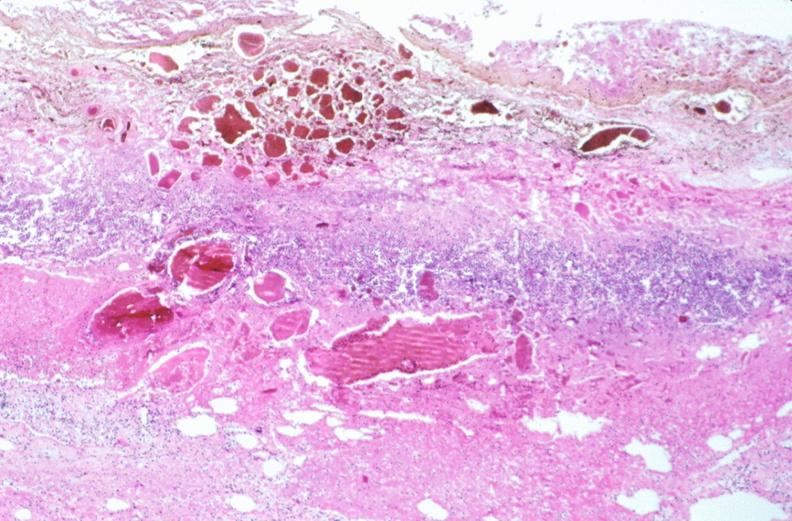what is present?
Answer the question using a single word or phrase. Gastrointestinal 